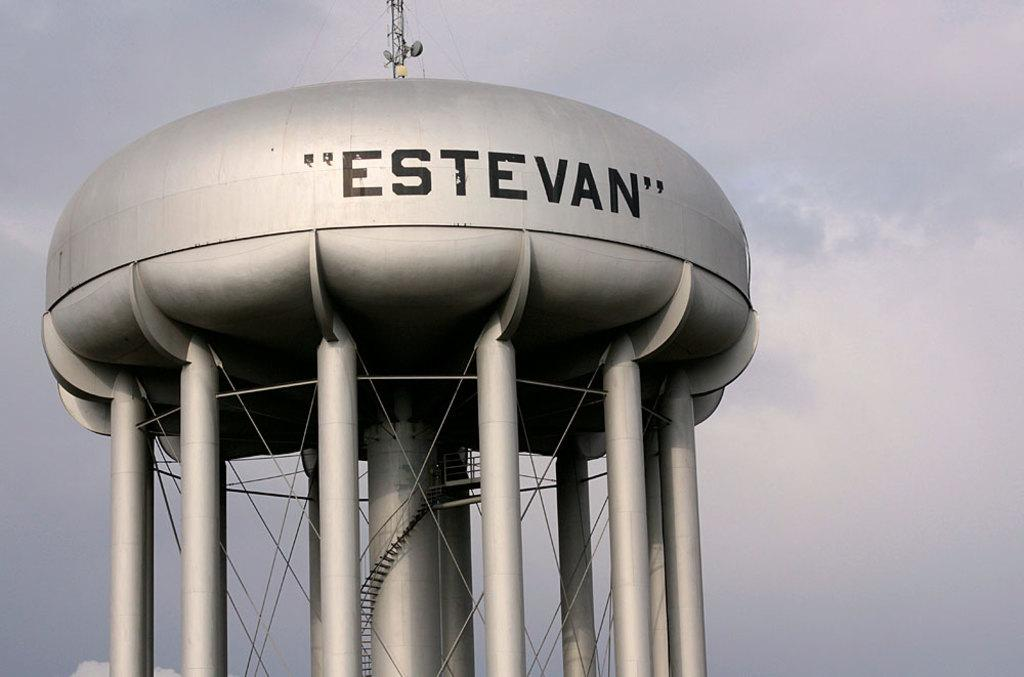Provide a one-sentence caption for the provided image. The grey water tower is called "Estevan" and has many legs. 